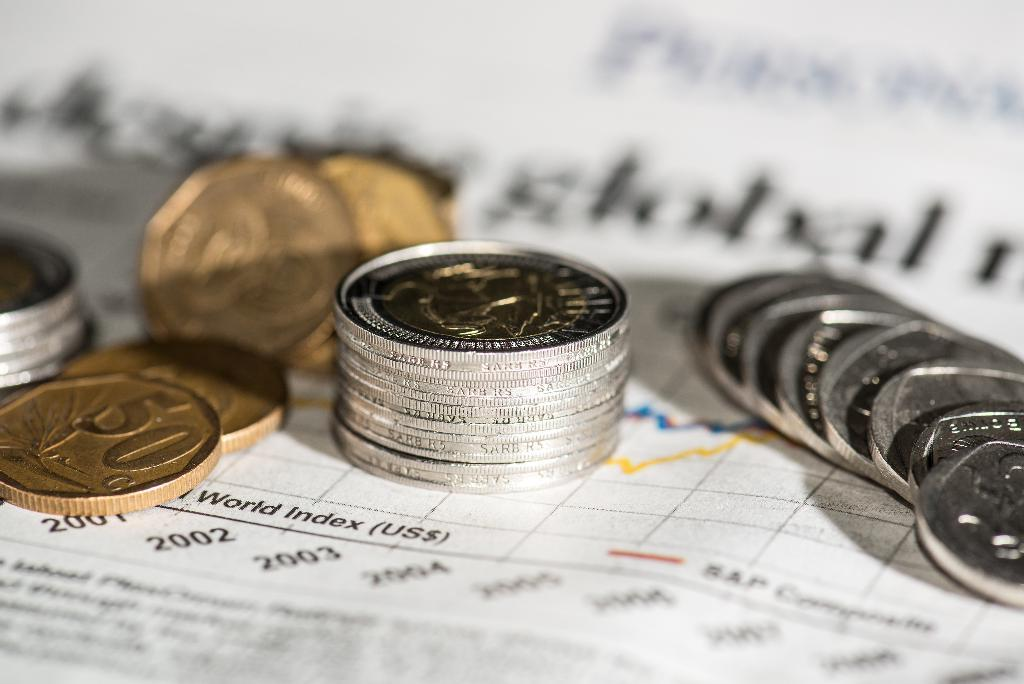<image>
Present a compact description of the photo's key features. A stack of gold and silver coins on top of a paper with world index printed on it. 